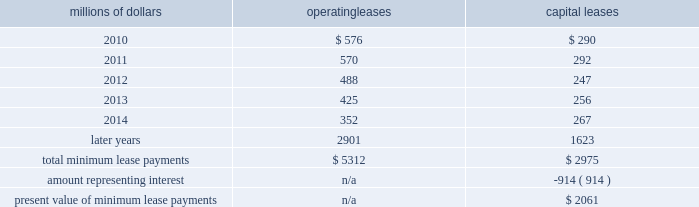14 .
Leases we lease certain locomotives , freight cars , and other property .
The consolidated statement of financial position as of december 31 , 2009 and 2008 included $ 2754 million , net of $ 927 million of accumulated depreciation , and $ 2024 million , net of $ 869 million of accumulated depreciation , respectively , for properties held under capital leases .
A charge to income resulting from the depreciation for assets held under capital leases is included within depreciation expense in our consolidated statements of income .
Future minimum lease payments for operating and capital leases with initial or remaining non-cancelable lease terms in excess of one year as of december 31 , 2009 were as follows : millions of dollars operating leases capital leases .
The majority of capital lease payments relate to locomotives .
Rent expense for operating leases with terms exceeding one month was $ 686 million in 2009 , $ 747 million in 2008 , and $ 810 million in 2007 .
When cash rental payments are not made on a straight-line basis , we recognize variable rental expense on a straight-line basis over the lease term .
Contingent rentals and sub-rentals are not significant .
15 .
Commitments and contingencies asserted and unasserted claims 2013 various claims and lawsuits are pending against us and certain of our subsidiaries .
We cannot fully determine the effect of all asserted and unasserted claims on our consolidated results of operations , financial condition , or liquidity ; however , to the extent possible , where asserted and unasserted claims are considered probable and where such claims can be reasonably estimated , we have recorded a liability .
We do not expect that any known lawsuits , claims , environmental costs , commitments , contingent liabilities , or guarantees will have a material adverse effect on our consolidated results of operations , financial condition , or liquidity after taking into account liabilities and insurance recoveries previously recorded for these matters .
Personal injury 2013 the cost of personal injuries to employees and others related to our activities is charged to expense based on estimates of the ultimate cost and number of incidents each year .
We use third-party actuaries to assist us in measuring the expense and liability , including unasserted claims .
The federal employers 2019 liability act ( fela ) governs compensation for work-related accidents .
Under fela , damages are assessed based on a finding of fault through litigation or out-of-court settlements .
We offer a comprehensive variety of services and rehabilitation programs for employees who are injured at .
What percent of total minimum operating lease payments are due in 2011? 
Computations: (570 / 5312)
Answer: 0.1073. 